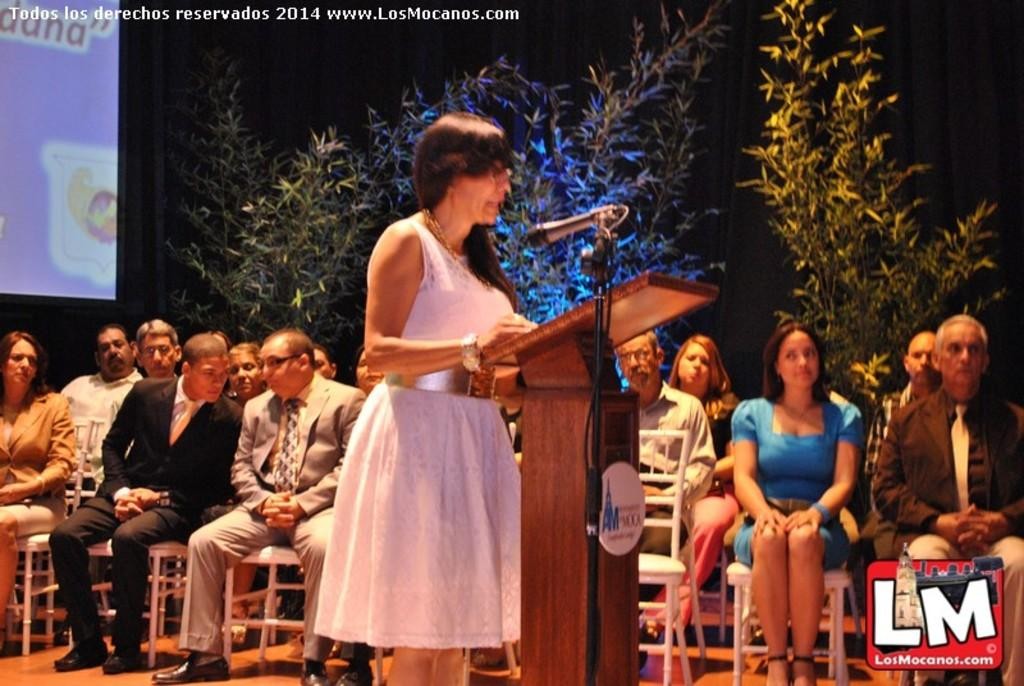What are the people in the image doing? There are persons sitting on chairs in the image, which suggests they might be attending an event or presentation. What is the woman near the podium doing? The woman standing near a podium in the image might be giving a speech or presentation. What can be seen in the background of the image? There is a projector display and plants in the background of the image. What type of window treatment is present in the background? There is a curtain in the background of the image. Can you tell me how many bananas are on the podium in the image? There are no bananas present on the podium or in the image. What type of wing is visible on the projector display in the image? There is no wing visible on the projector display or in the image. 